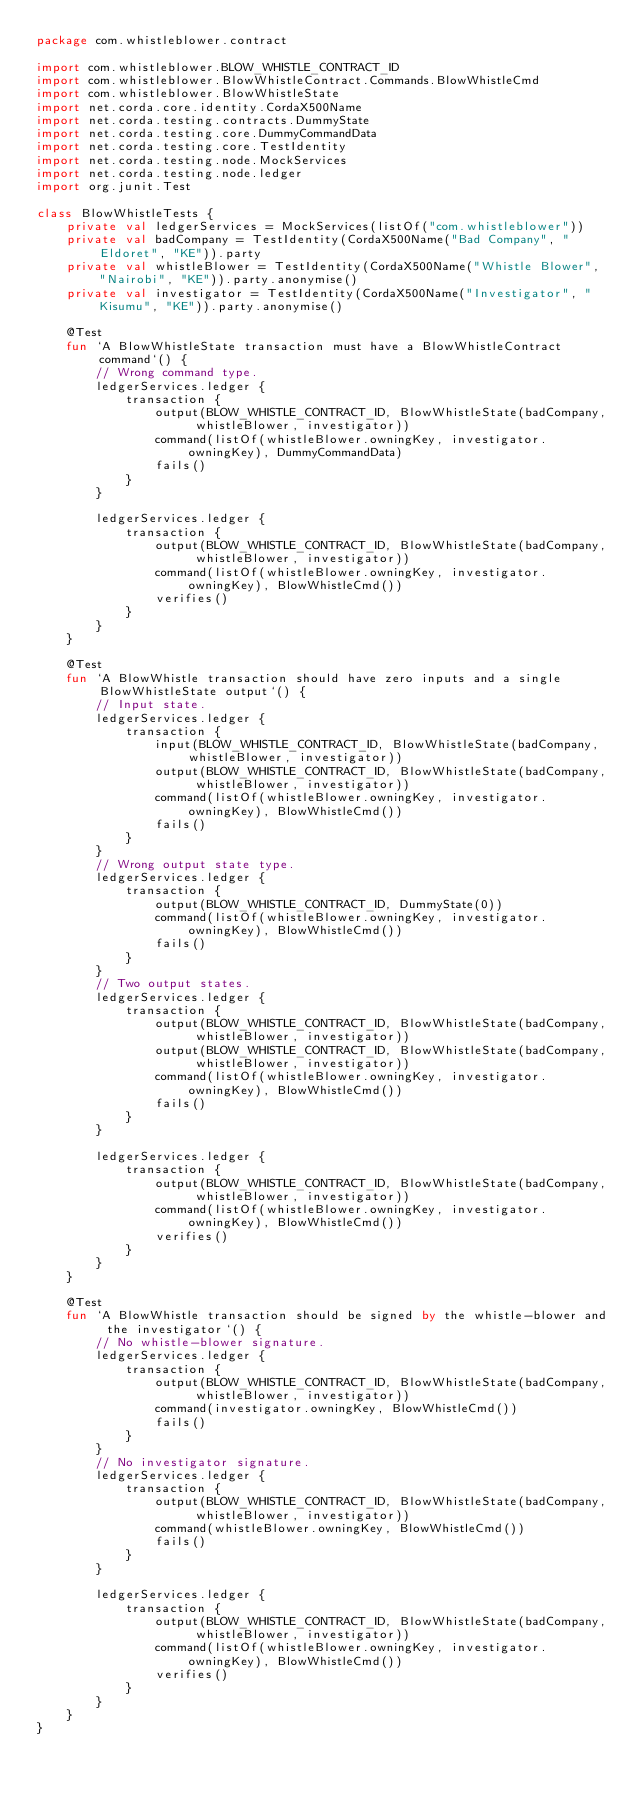<code> <loc_0><loc_0><loc_500><loc_500><_Kotlin_>package com.whistleblower.contract

import com.whistleblower.BLOW_WHISTLE_CONTRACT_ID
import com.whistleblower.BlowWhistleContract.Commands.BlowWhistleCmd
import com.whistleblower.BlowWhistleState
import net.corda.core.identity.CordaX500Name
import net.corda.testing.contracts.DummyState
import net.corda.testing.core.DummyCommandData
import net.corda.testing.core.TestIdentity
import net.corda.testing.node.MockServices
import net.corda.testing.node.ledger
import org.junit.Test

class BlowWhistleTests {
    private val ledgerServices = MockServices(listOf("com.whistleblower"))
    private val badCompany = TestIdentity(CordaX500Name("Bad Company", "Eldoret", "KE")).party
    private val whistleBlower = TestIdentity(CordaX500Name("Whistle Blower", "Nairobi", "KE")).party.anonymise()
    private val investigator = TestIdentity(CordaX500Name("Investigator", "Kisumu", "KE")).party.anonymise()

    @Test
    fun `A BlowWhistleState transaction must have a BlowWhistleContract command`() {
        // Wrong command type.
        ledgerServices.ledger {
            transaction {
                output(BLOW_WHISTLE_CONTRACT_ID, BlowWhistleState(badCompany, whistleBlower, investigator))
                command(listOf(whistleBlower.owningKey, investigator.owningKey), DummyCommandData)
                fails()
            }
        }

        ledgerServices.ledger {
            transaction {
                output(BLOW_WHISTLE_CONTRACT_ID, BlowWhistleState(badCompany, whistleBlower, investigator))
                command(listOf(whistleBlower.owningKey, investigator.owningKey), BlowWhistleCmd())
                verifies()
            }
        }
    }

    @Test
    fun `A BlowWhistle transaction should have zero inputs and a single BlowWhistleState output`() {
        // Input state.
        ledgerServices.ledger {
            transaction {
                input(BLOW_WHISTLE_CONTRACT_ID, BlowWhistleState(badCompany, whistleBlower, investigator))
                output(BLOW_WHISTLE_CONTRACT_ID, BlowWhistleState(badCompany, whistleBlower, investigator))
                command(listOf(whistleBlower.owningKey, investigator.owningKey), BlowWhistleCmd())
                fails()
            }
        }
        // Wrong output state type.
        ledgerServices.ledger {
            transaction {
                output(BLOW_WHISTLE_CONTRACT_ID, DummyState(0))
                command(listOf(whistleBlower.owningKey, investigator.owningKey), BlowWhistleCmd())
                fails()
            }
        }
        // Two output states.
        ledgerServices.ledger {
            transaction {
                output(BLOW_WHISTLE_CONTRACT_ID, BlowWhistleState(badCompany, whistleBlower, investigator))
                output(BLOW_WHISTLE_CONTRACT_ID, BlowWhistleState(badCompany, whistleBlower, investigator))
                command(listOf(whistleBlower.owningKey, investigator.owningKey), BlowWhistleCmd())
                fails()
            }
        }

        ledgerServices.ledger {
            transaction {
                output(BLOW_WHISTLE_CONTRACT_ID, BlowWhistleState(badCompany, whistleBlower, investigator))
                command(listOf(whistleBlower.owningKey, investigator.owningKey), BlowWhistleCmd())
                verifies()
            }
        }
    }

    @Test
    fun `A BlowWhistle transaction should be signed by the whistle-blower and the investigator`() {
        // No whistle-blower signature.
        ledgerServices.ledger {
            transaction {
                output(BLOW_WHISTLE_CONTRACT_ID, BlowWhistleState(badCompany, whistleBlower, investigator))
                command(investigator.owningKey, BlowWhistleCmd())
                fails()
            }
        }
        // No investigator signature.
        ledgerServices.ledger {
            transaction {
                output(BLOW_WHISTLE_CONTRACT_ID, BlowWhistleState(badCompany, whistleBlower, investigator))
                command(whistleBlower.owningKey, BlowWhistleCmd())
                fails()
            }
        }

        ledgerServices.ledger {
            transaction {
                output(BLOW_WHISTLE_CONTRACT_ID, BlowWhistleState(badCompany, whistleBlower, investigator))
                command(listOf(whistleBlower.owningKey, investigator.owningKey), BlowWhistleCmd())
                verifies()
            }
        }
    }
}</code> 